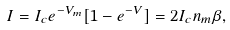<formula> <loc_0><loc_0><loc_500><loc_500>I = I _ { c } e ^ { - V _ { m } } [ 1 - e ^ { - V } ] = 2 I _ { c } n _ { m } \beta ,</formula> 